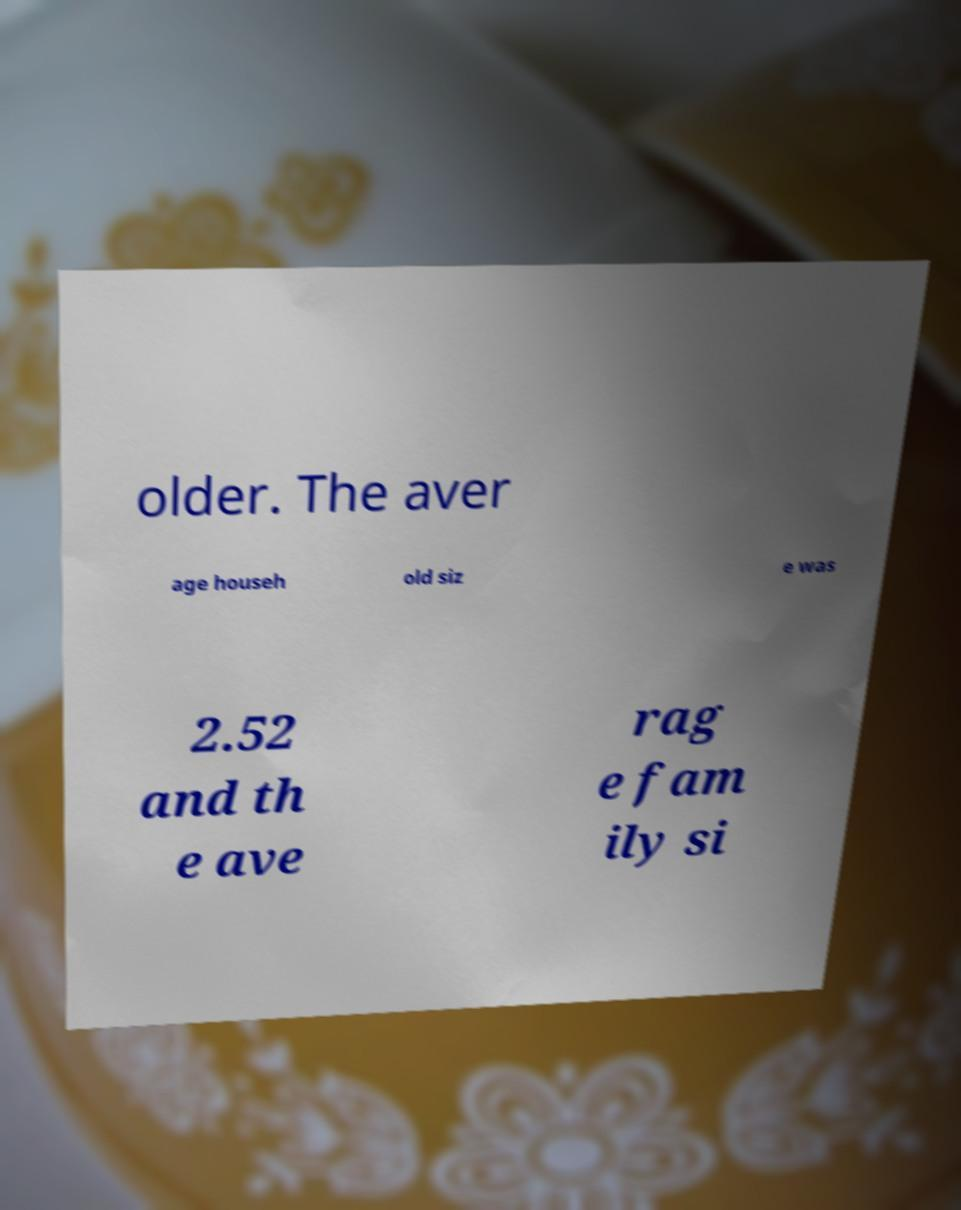Could you extract and type out the text from this image? older. The aver age househ old siz e was 2.52 and th e ave rag e fam ily si 